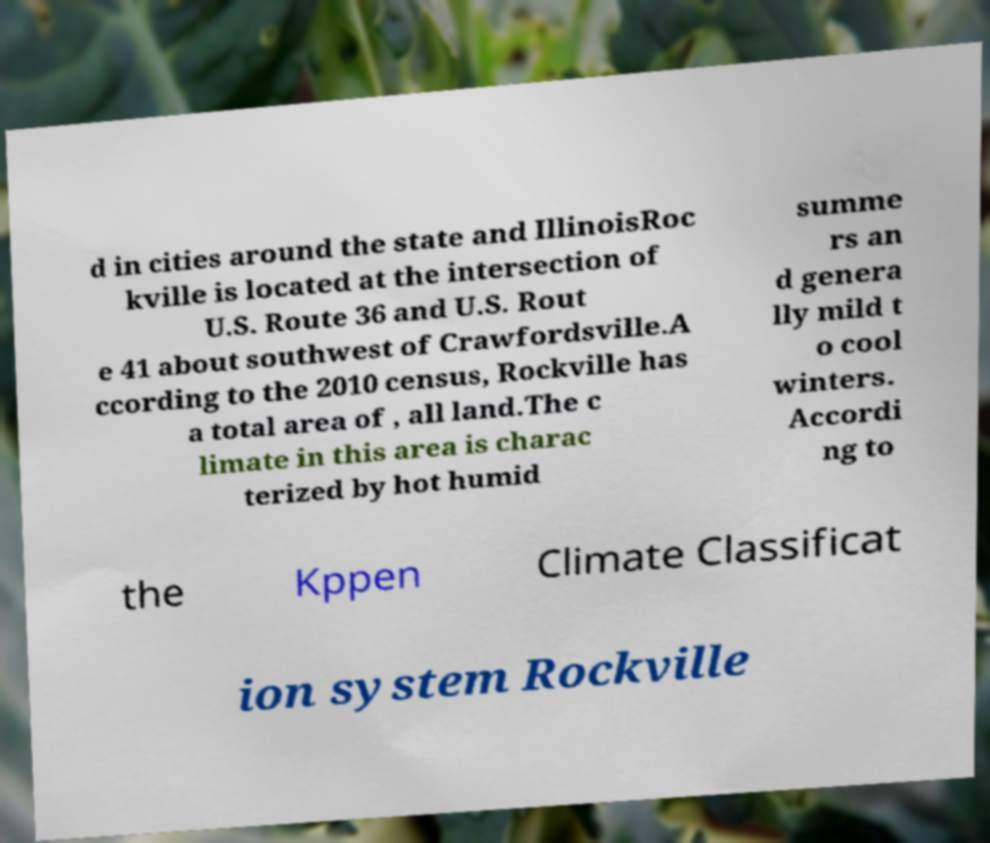There's text embedded in this image that I need extracted. Can you transcribe it verbatim? d in cities around the state and IllinoisRoc kville is located at the intersection of U.S. Route 36 and U.S. Rout e 41 about southwest of Crawfordsville.A ccording to the 2010 census, Rockville has a total area of , all land.The c limate in this area is charac terized by hot humid summe rs an d genera lly mild t o cool winters. Accordi ng to the Kppen Climate Classificat ion system Rockville 